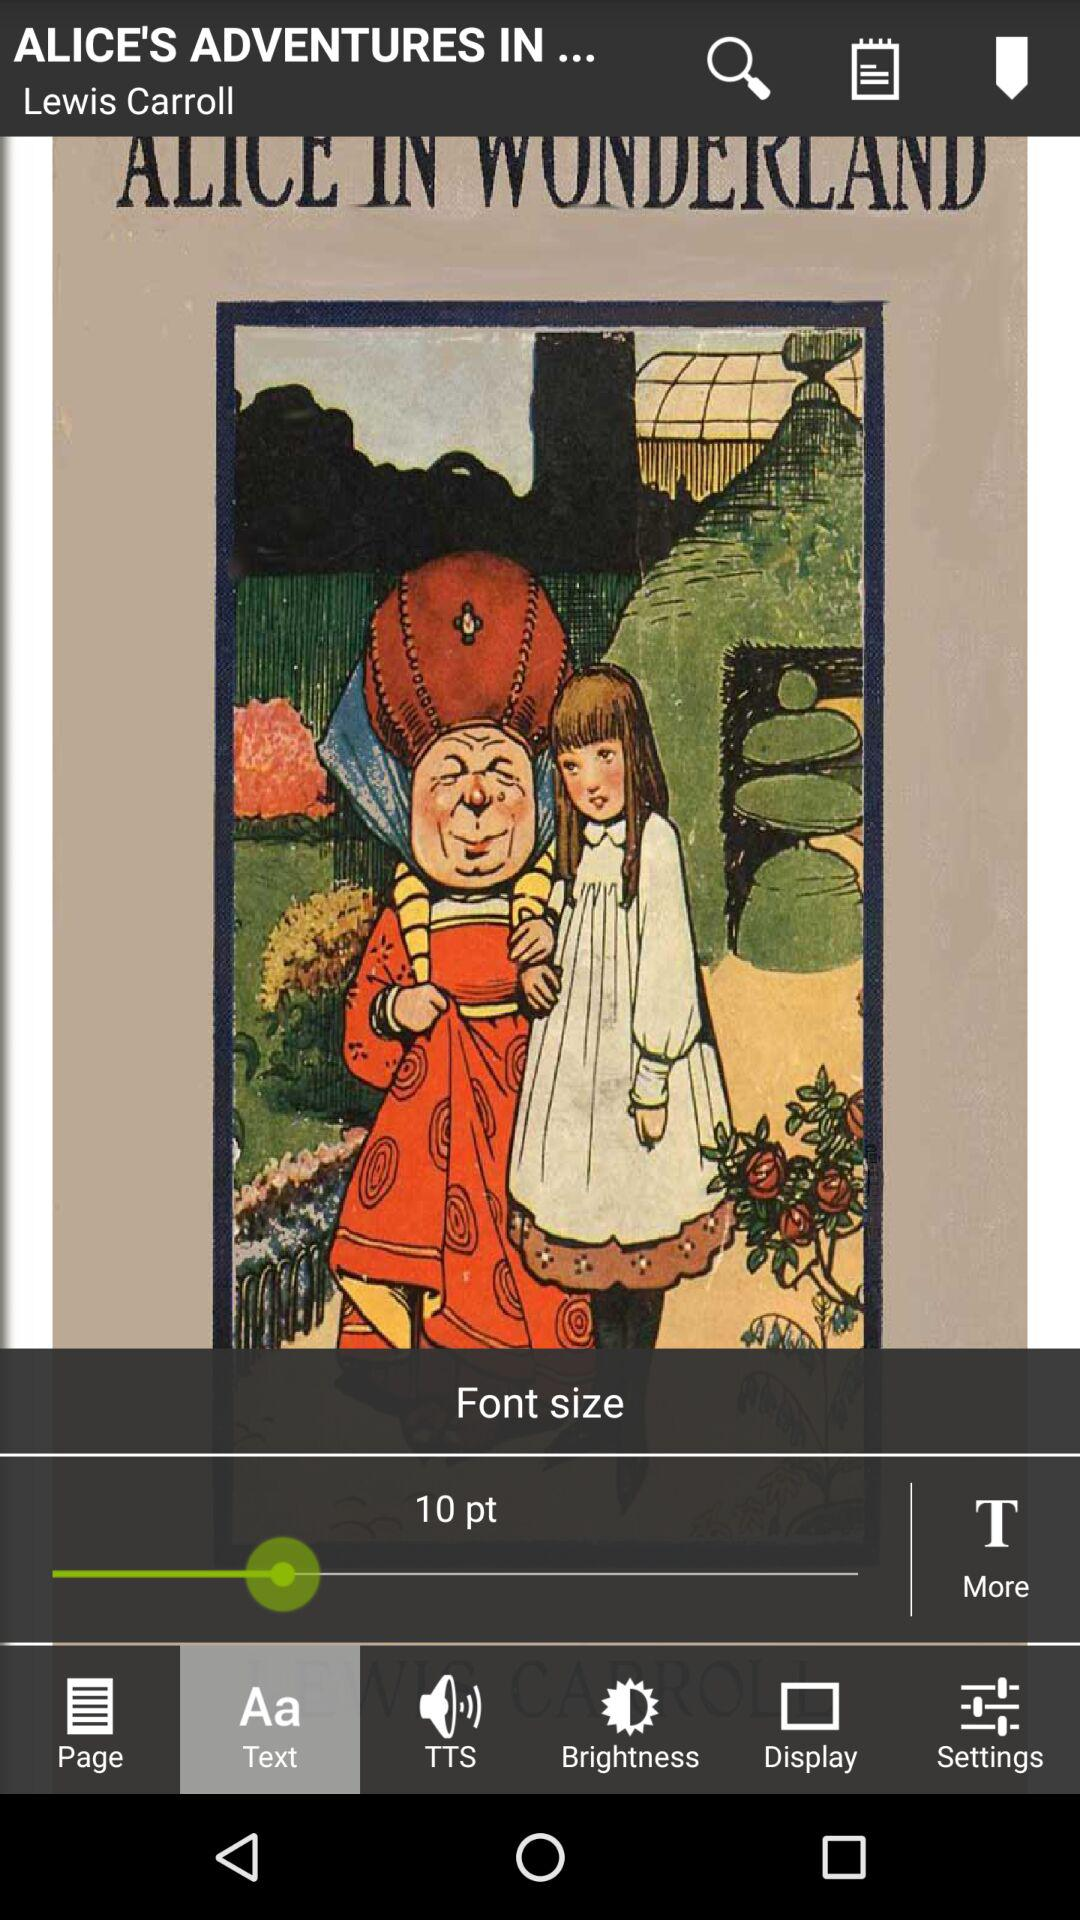Which tab has been selected? The tab that has been selected is "Text". 